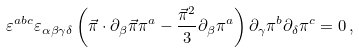<formula> <loc_0><loc_0><loc_500><loc_500>\varepsilon ^ { a b c } \varepsilon _ { \alpha \beta \gamma \delta } \left ( \vec { \pi } \cdot \partial _ { \beta } \vec { \pi } \pi ^ { a } - \frac { \vec { \pi } ^ { 2 } } { 3 } \partial _ { \beta } \pi ^ { a } \right ) \partial _ { \gamma } \pi ^ { b } \partial _ { \delta } \pi ^ { c } = 0 \, ,</formula> 